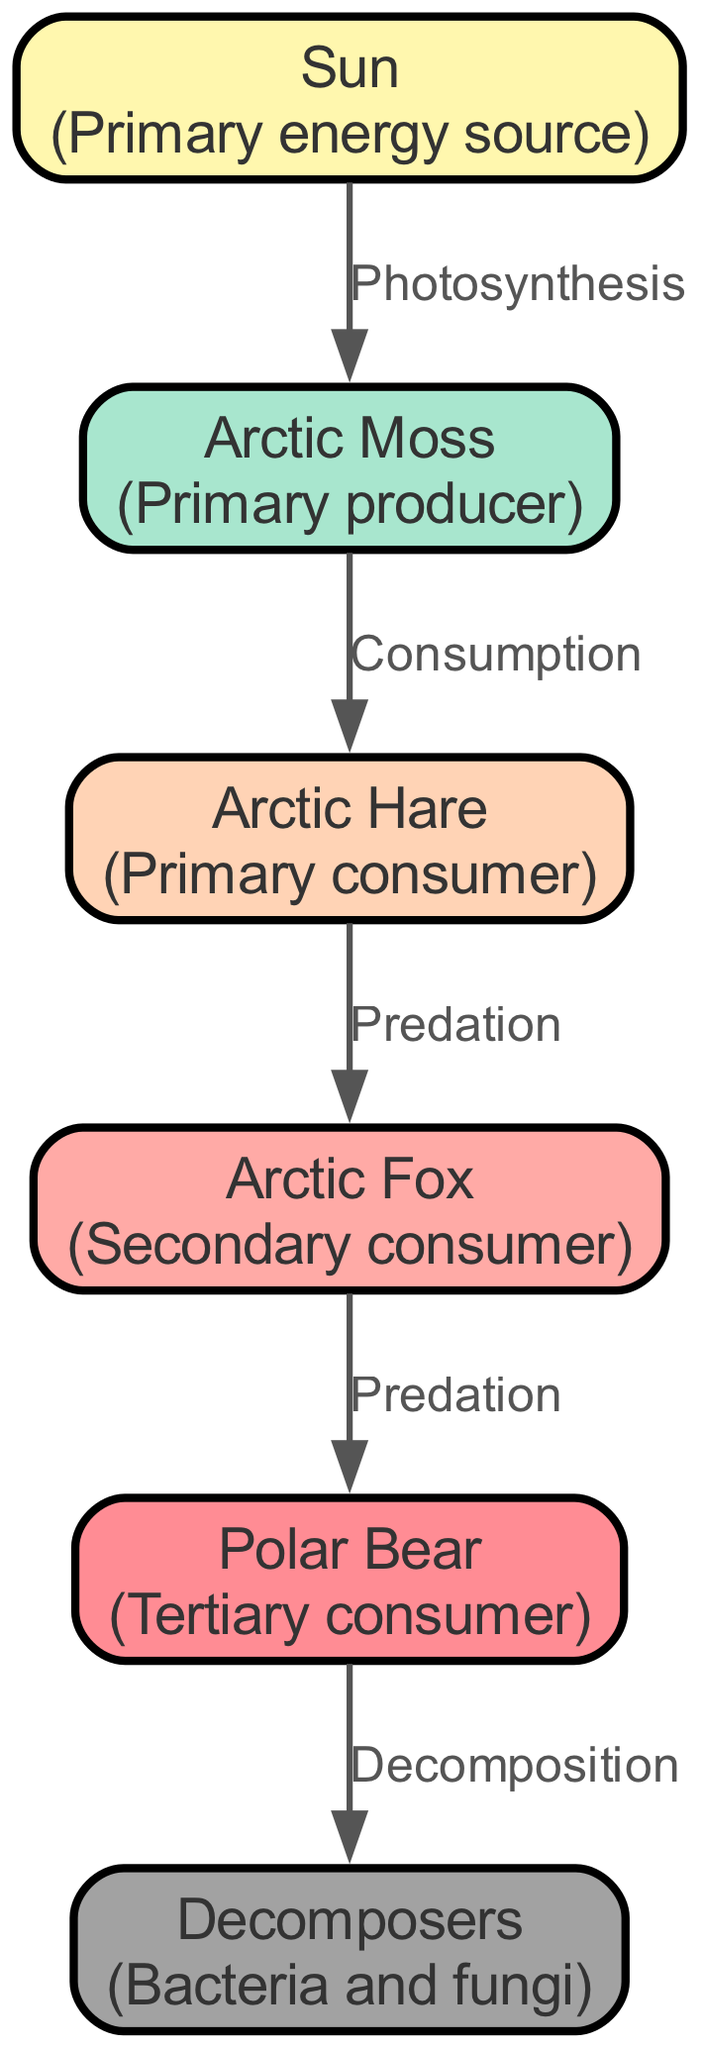What is the primary energy source in the Arctic tundra food chain? The diagram indicates that the primary energy source is represented by the "Sun" node. This is the starting point and the first entry in the list of organisms, designated as level 0.
Answer: Sun How many primary consumers are in the food chain? According to the diagram, the "Arctic Hare" is the only primary consumer listed (level 2). Counting the nodes, we find there is just one.
Answer: 1 What is the relationship between the Arctic Moss and the Arctic Hare? The diagram shows an edge labeled "Consumption" connecting "Arctic Moss" to "Arctic Hare." This indicates that the Arctic Hare consumes the Arctic Moss, establishing a direct feeding relationship.
Answer: Consumption Which organism is at the highest trophic level in this food chain? The "Polar Bear" is at level 4, making it the highest trophic level organism in the food chain diagram as it is the last consumer before the decomposers.
Answer: Polar Bear What role do decomposers play in the Arctic tundra food chain? Decomposers are represented by the last node in the diagram (level 5) and are shown to receive energy through "Decomposition" from the "Polar Bear," indicating their role in breaking down organic material.
Answer: Decomposition How do energy transfers occur from the Arctic Fox to the Polar Bear? The diagram displays an edge labeled "Predation" connecting the "Arctic Fox" to the "Polar Bear." This illustrates that the Arctic Fox is a prey item for the Polar Bear, transferring energy between these two organisms through predation.
Answer: Predation What process occurs when the Arctic Moss utilizes energy from the Sun? The diagram indicates this process as "Photosynthesis," linking the "Sun" to "Arctic Moss," which signifies how the moss converts solar energy into usable chemical energy.
Answer: Photosynthesis How many total organisms are present in the food chain diagram? By counting the organisms listed in the diagram (Sun, Arctic Moss, Arctic Hare, Arctic Fox, Polar Bear, and Decomposers), we find there are six organisms total.
Answer: 6 